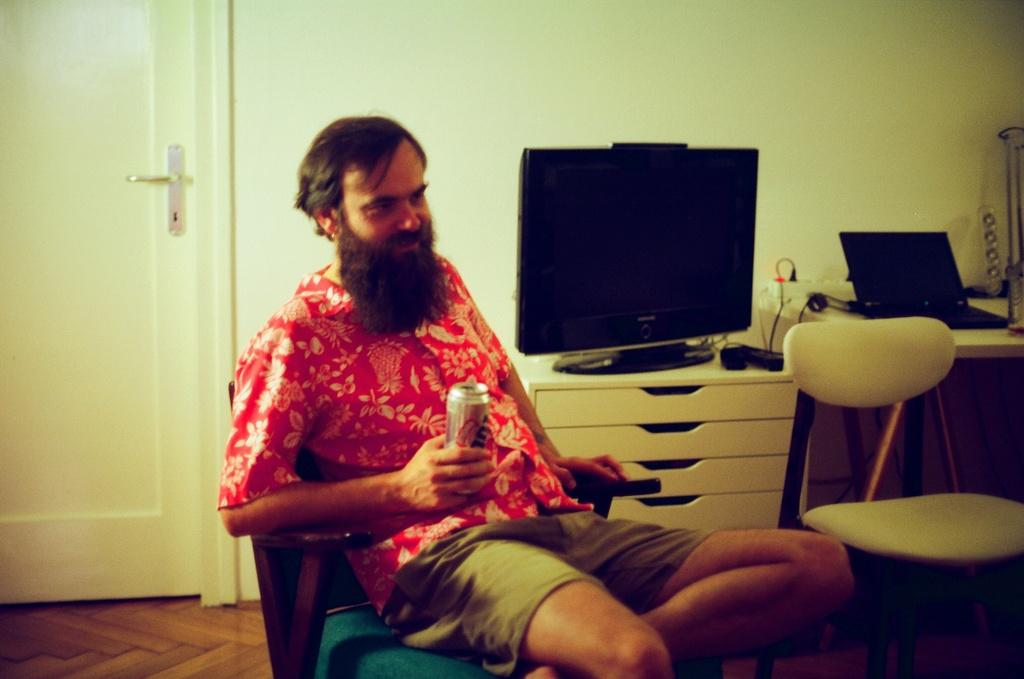Who is present in the image? There is a man in the image. What is the man doing in the image? The man is sitting in the image. What is the man holding in his hand? The man is holding a can in his hand. What is on the table in the image? There is a TV on the table in the image. How many boys are playing an instrument in the image? There are no boys or instruments present in the image. 